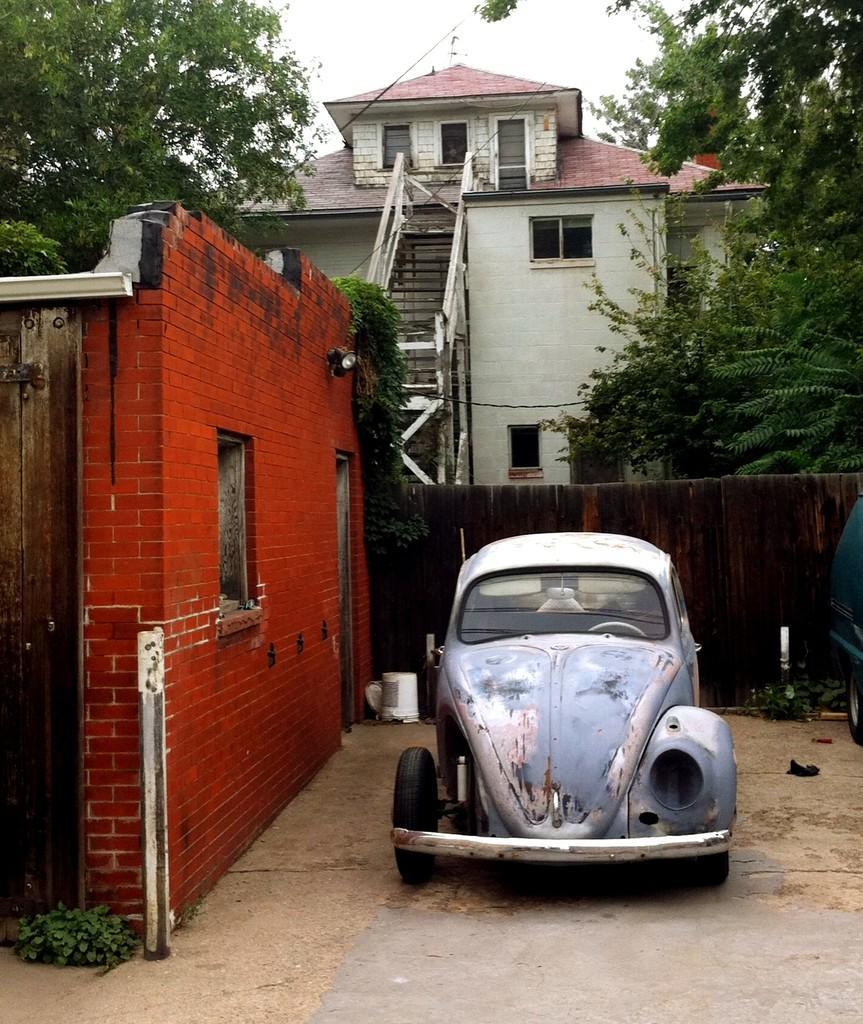Describe this image in one or two sentences. In this image there are houses, steps, trees, vehicles, plants, sky, fence and objects. 